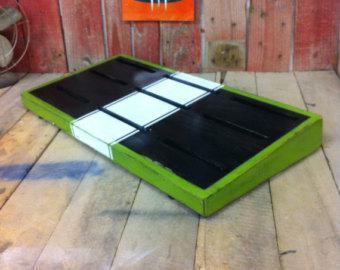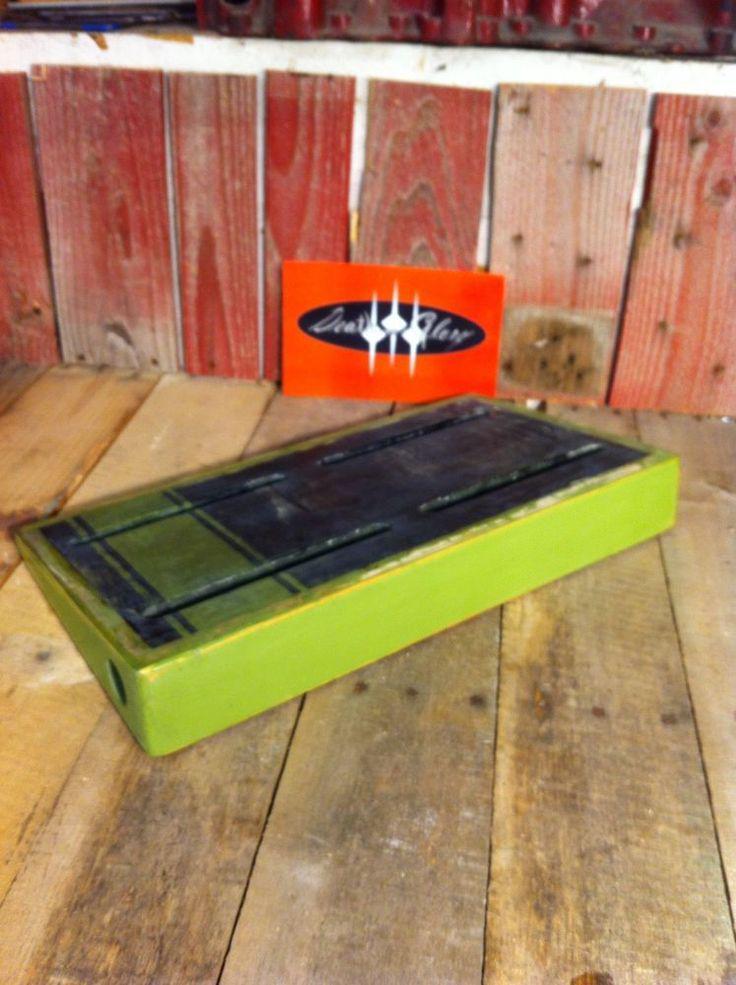The first image is the image on the left, the second image is the image on the right. Examine the images to the left and right. Is the description "The left and right image contains the same number of orange rectangle blocks with three white dots." accurate? Answer yes or no. Yes. The first image is the image on the left, the second image is the image on the right. Assess this claim about the two images: "Both items are sitting on wood planks.". Correct or not? Answer yes or no. Yes. 